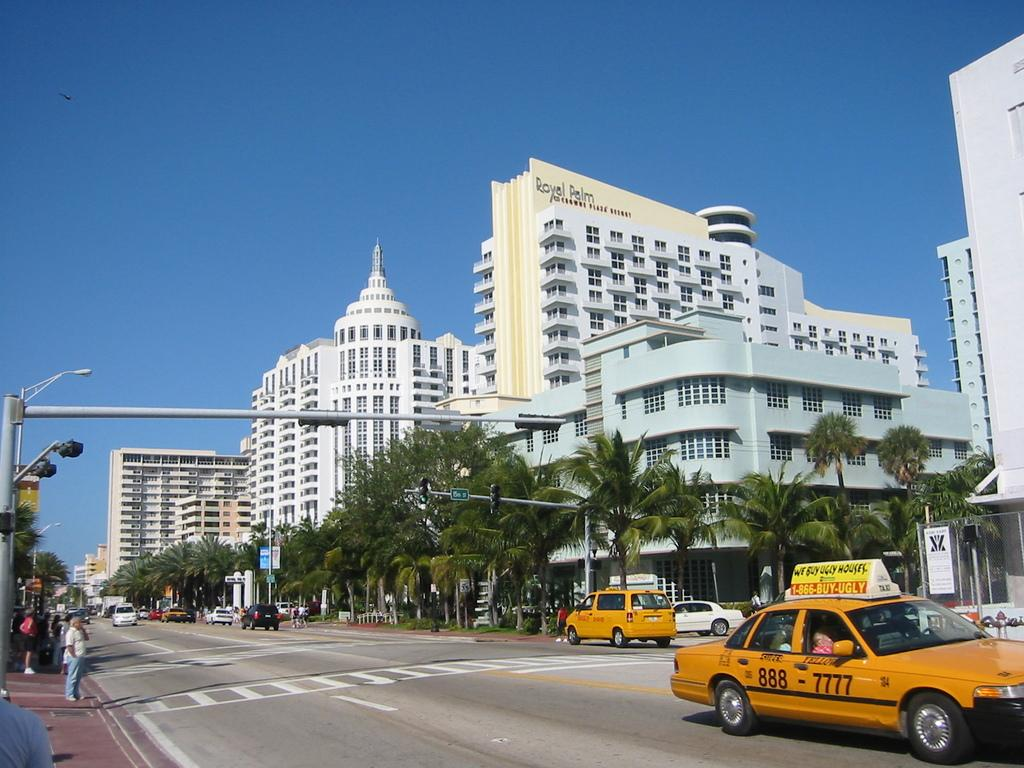Provide a one-sentence caption for the provided image. A yellow taxi that has the number 888-7777 on it is going through a city intersection. 